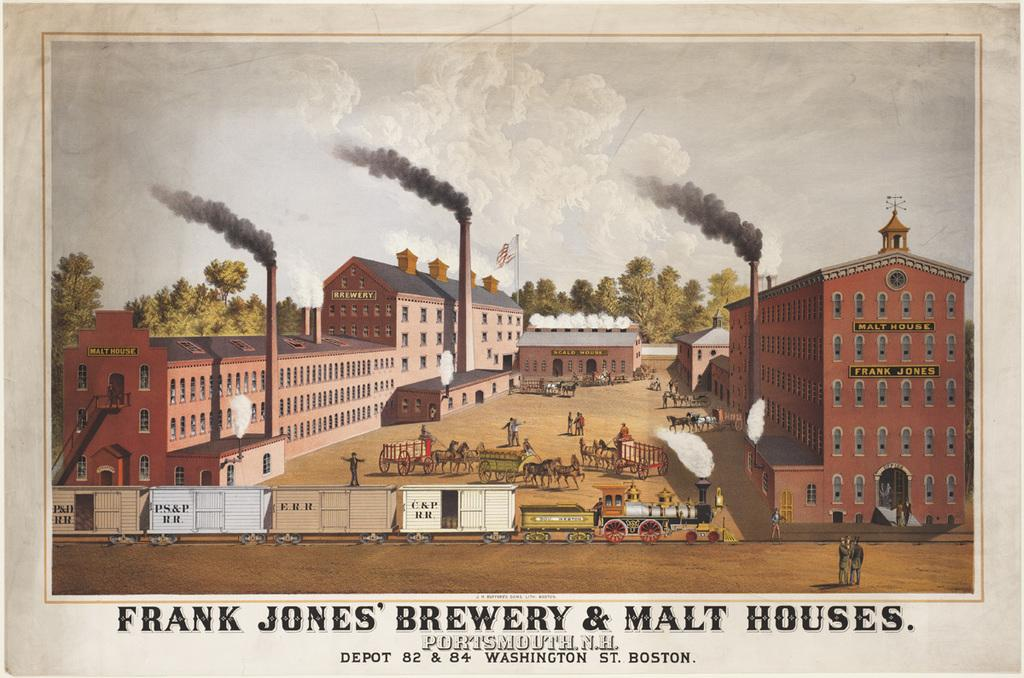<image>
Describe the image concisely. The buildings that make up Frank Jones' Brewery & Malt Houses. 